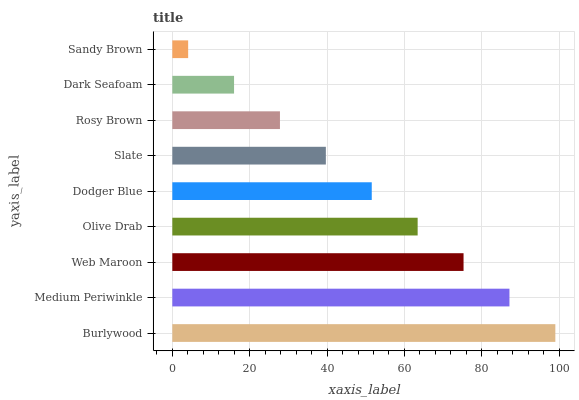Is Sandy Brown the minimum?
Answer yes or no. Yes. Is Burlywood the maximum?
Answer yes or no. Yes. Is Medium Periwinkle the minimum?
Answer yes or no. No. Is Medium Periwinkle the maximum?
Answer yes or no. No. Is Burlywood greater than Medium Periwinkle?
Answer yes or no. Yes. Is Medium Periwinkle less than Burlywood?
Answer yes or no. Yes. Is Medium Periwinkle greater than Burlywood?
Answer yes or no. No. Is Burlywood less than Medium Periwinkle?
Answer yes or no. No. Is Dodger Blue the high median?
Answer yes or no. Yes. Is Dodger Blue the low median?
Answer yes or no. Yes. Is Sandy Brown the high median?
Answer yes or no. No. Is Rosy Brown the low median?
Answer yes or no. No. 